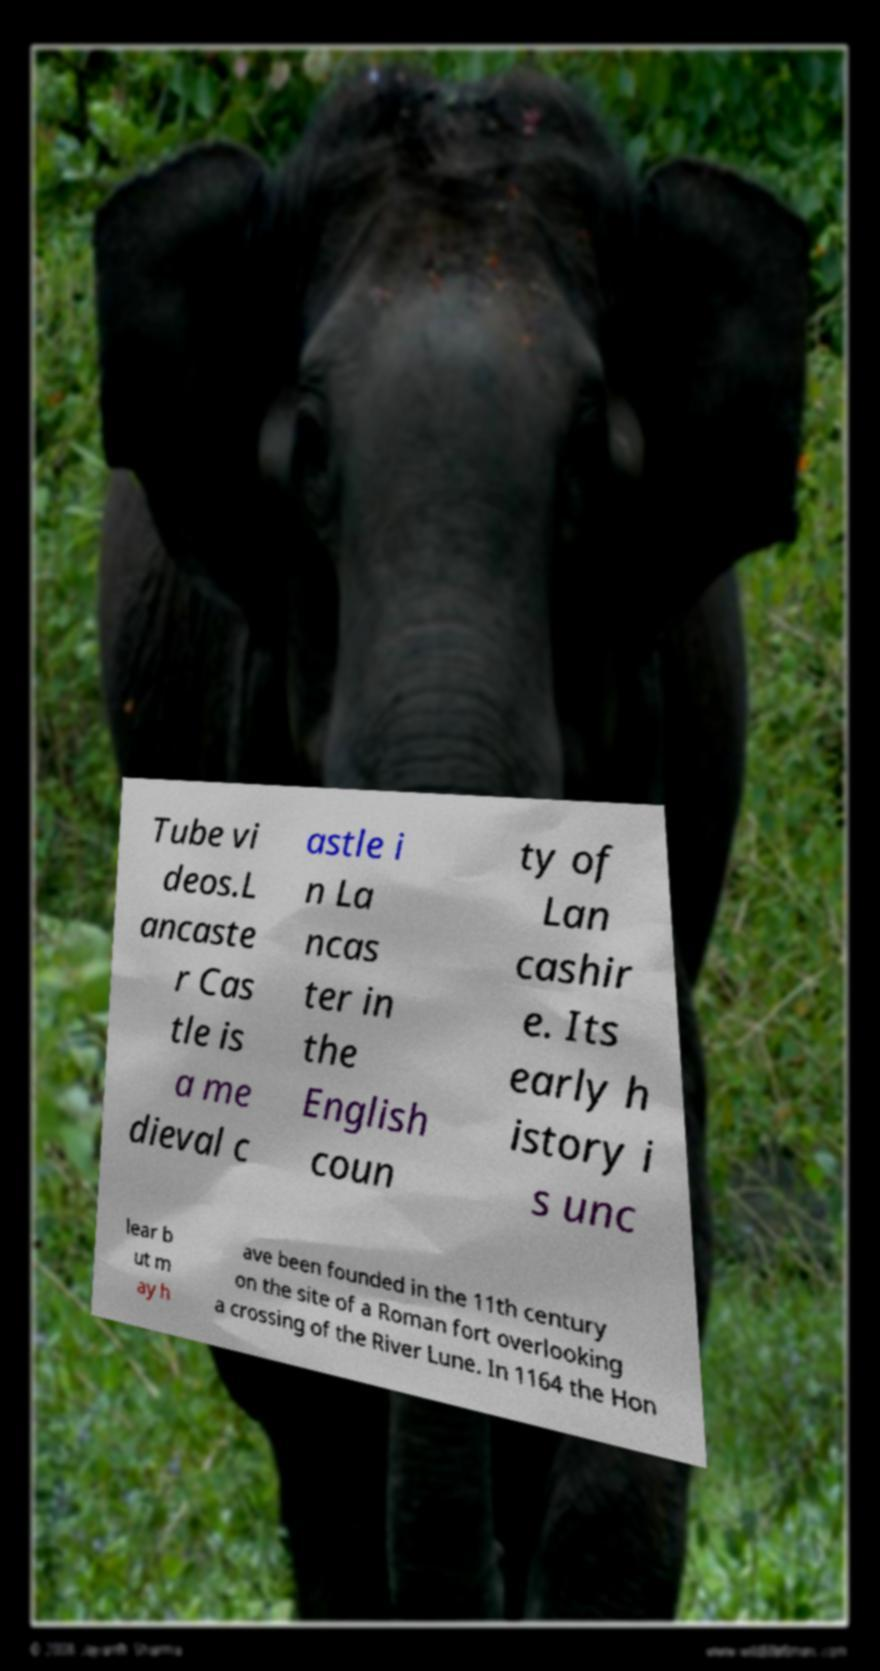I need the written content from this picture converted into text. Can you do that? Tube vi deos.L ancaste r Cas tle is a me dieval c astle i n La ncas ter in the English coun ty of Lan cashir e. Its early h istory i s unc lear b ut m ay h ave been founded in the 11th century on the site of a Roman fort overlooking a crossing of the River Lune. In 1164 the Hon 